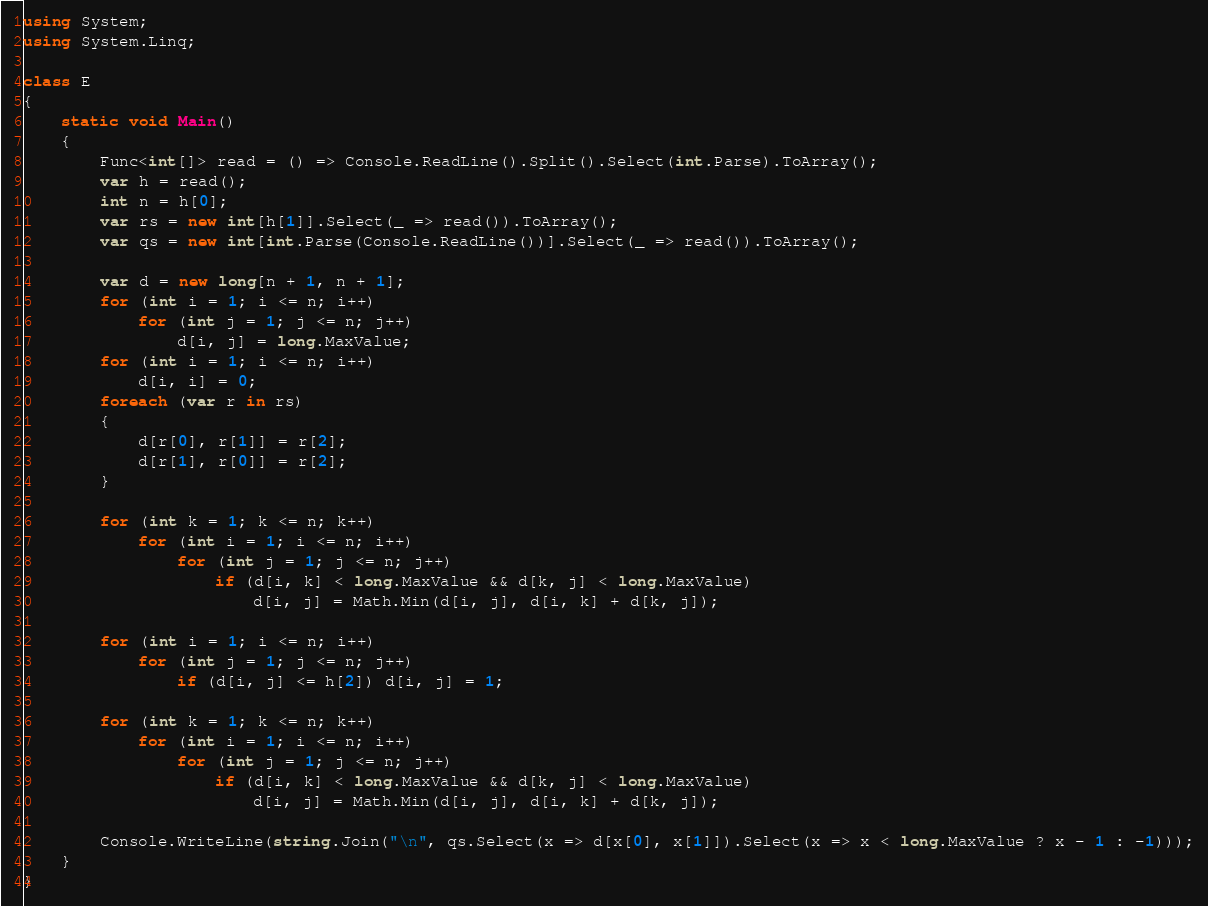Convert code to text. <code><loc_0><loc_0><loc_500><loc_500><_C#_>using System;
using System.Linq;

class E
{
	static void Main()
	{
		Func<int[]> read = () => Console.ReadLine().Split().Select(int.Parse).ToArray();
		var h = read();
		int n = h[0];
		var rs = new int[h[1]].Select(_ => read()).ToArray();
		var qs = new int[int.Parse(Console.ReadLine())].Select(_ => read()).ToArray();

		var d = new long[n + 1, n + 1];
		for (int i = 1; i <= n; i++)
			for (int j = 1; j <= n; j++)
				d[i, j] = long.MaxValue;
		for (int i = 1; i <= n; i++)
			d[i, i] = 0;
		foreach (var r in rs)
		{
			d[r[0], r[1]] = r[2];
			d[r[1], r[0]] = r[2];
		}

		for (int k = 1; k <= n; k++)
			for (int i = 1; i <= n; i++)
				for (int j = 1; j <= n; j++)
					if (d[i, k] < long.MaxValue && d[k, j] < long.MaxValue)
						d[i, j] = Math.Min(d[i, j], d[i, k] + d[k, j]);

		for (int i = 1; i <= n; i++)
			for (int j = 1; j <= n; j++)
				if (d[i, j] <= h[2]) d[i, j] = 1;

		for (int k = 1; k <= n; k++)
			for (int i = 1; i <= n; i++)
				for (int j = 1; j <= n; j++)
					if (d[i, k] < long.MaxValue && d[k, j] < long.MaxValue)
						d[i, j] = Math.Min(d[i, j], d[i, k] + d[k, j]);

		Console.WriteLine(string.Join("\n", qs.Select(x => d[x[0], x[1]]).Select(x => x < long.MaxValue ? x - 1 : -1)));
	}
}
</code> 